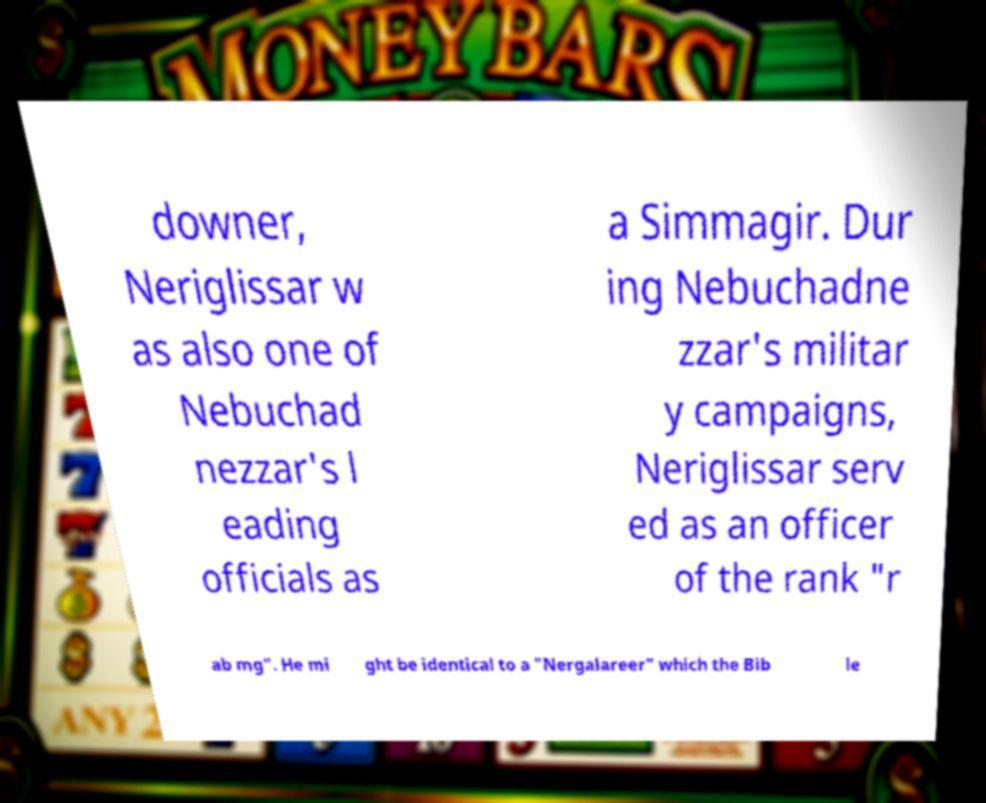Can you read and provide the text displayed in the image?This photo seems to have some interesting text. Can you extract and type it out for me? downer, Neriglissar w as also one of Nebuchad nezzar's l eading officials as a Simmagir. Dur ing Nebuchadne zzar's militar y campaigns, Neriglissar serv ed as an officer of the rank "r ab mg". He mi ght be identical to a "Nergalareer" which the Bib le 